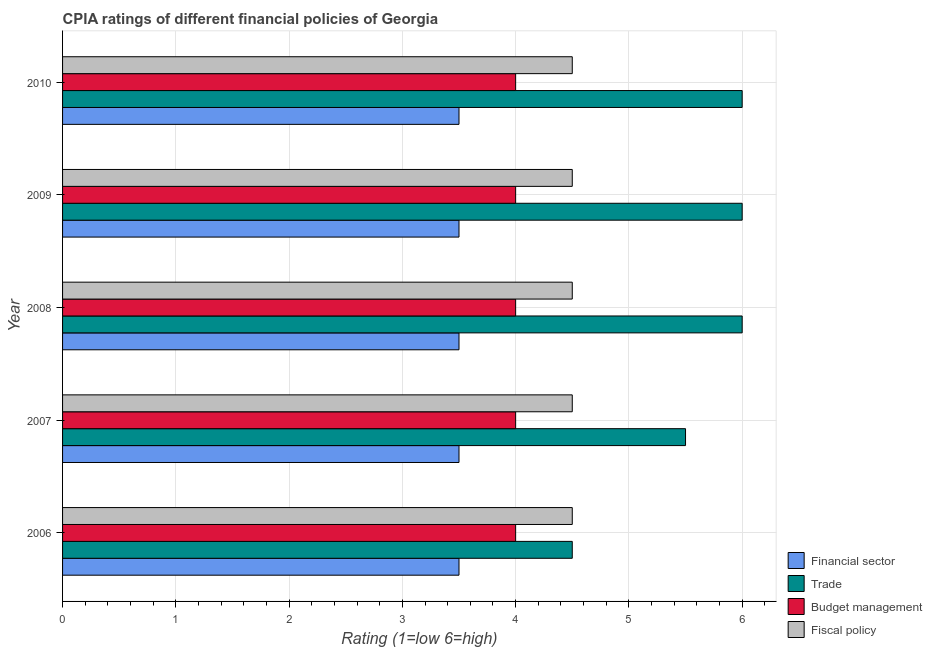How many groups of bars are there?
Provide a succinct answer. 5. How many bars are there on the 5th tick from the bottom?
Your response must be concise. 4. What is the label of the 2nd group of bars from the top?
Ensure brevity in your answer.  2009. In how many cases, is the number of bars for a given year not equal to the number of legend labels?
Keep it short and to the point. 0. What is the cpia rating of fiscal policy in 2010?
Make the answer very short. 4.5. In which year was the cpia rating of financial sector maximum?
Give a very brief answer. 2006. What is the total cpia rating of fiscal policy in the graph?
Provide a succinct answer. 22.5. What is the difference between the cpia rating of fiscal policy in 2009 and that in 2010?
Keep it short and to the point. 0. What is the difference between the cpia rating of fiscal policy in 2009 and the cpia rating of budget management in 2006?
Offer a very short reply. 0.5. What is the average cpia rating of budget management per year?
Give a very brief answer. 4. In the year 2010, what is the difference between the cpia rating of financial sector and cpia rating of fiscal policy?
Make the answer very short. -1. What is the difference between the highest and the second highest cpia rating of financial sector?
Ensure brevity in your answer.  0. What is the difference between the highest and the lowest cpia rating of financial sector?
Your answer should be compact. 0. Is the sum of the cpia rating of budget management in 2007 and 2008 greater than the maximum cpia rating of fiscal policy across all years?
Offer a terse response. Yes. What does the 3rd bar from the top in 2008 represents?
Your answer should be compact. Trade. What does the 3rd bar from the bottom in 2008 represents?
Provide a succinct answer. Budget management. Is it the case that in every year, the sum of the cpia rating of financial sector and cpia rating of trade is greater than the cpia rating of budget management?
Provide a short and direct response. Yes. How many bars are there?
Keep it short and to the point. 20. What is the difference between two consecutive major ticks on the X-axis?
Provide a short and direct response. 1. Are the values on the major ticks of X-axis written in scientific E-notation?
Your answer should be very brief. No. Does the graph contain any zero values?
Make the answer very short. No. Does the graph contain grids?
Provide a succinct answer. Yes. How many legend labels are there?
Offer a very short reply. 4. How are the legend labels stacked?
Offer a very short reply. Vertical. What is the title of the graph?
Your response must be concise. CPIA ratings of different financial policies of Georgia. Does "UNDP" appear as one of the legend labels in the graph?
Give a very brief answer. No. What is the Rating (1=low 6=high) of Financial sector in 2006?
Ensure brevity in your answer.  3.5. What is the Rating (1=low 6=high) of Trade in 2006?
Offer a very short reply. 4.5. What is the Rating (1=low 6=high) of Budget management in 2006?
Make the answer very short. 4. What is the Rating (1=low 6=high) of Fiscal policy in 2006?
Make the answer very short. 4.5. What is the Rating (1=low 6=high) in Trade in 2007?
Your answer should be very brief. 5.5. What is the Rating (1=low 6=high) in Budget management in 2007?
Provide a succinct answer. 4. What is the Rating (1=low 6=high) of Fiscal policy in 2008?
Offer a terse response. 4.5. What is the Rating (1=low 6=high) in Financial sector in 2009?
Make the answer very short. 3.5. What is the Rating (1=low 6=high) in Fiscal policy in 2009?
Your answer should be compact. 4.5. Across all years, what is the minimum Rating (1=low 6=high) in Financial sector?
Provide a short and direct response. 3.5. Across all years, what is the minimum Rating (1=low 6=high) of Budget management?
Your response must be concise. 4. Across all years, what is the minimum Rating (1=low 6=high) of Fiscal policy?
Ensure brevity in your answer.  4.5. What is the total Rating (1=low 6=high) in Trade in the graph?
Offer a very short reply. 28. What is the difference between the Rating (1=low 6=high) of Fiscal policy in 2006 and that in 2007?
Provide a succinct answer. 0. What is the difference between the Rating (1=low 6=high) in Financial sector in 2006 and that in 2008?
Ensure brevity in your answer.  0. What is the difference between the Rating (1=low 6=high) in Fiscal policy in 2006 and that in 2008?
Your response must be concise. 0. What is the difference between the Rating (1=low 6=high) of Financial sector in 2006 and that in 2009?
Give a very brief answer. 0. What is the difference between the Rating (1=low 6=high) of Budget management in 2006 and that in 2009?
Offer a very short reply. 0. What is the difference between the Rating (1=low 6=high) of Fiscal policy in 2006 and that in 2009?
Offer a terse response. 0. What is the difference between the Rating (1=low 6=high) of Financial sector in 2006 and that in 2010?
Your response must be concise. 0. What is the difference between the Rating (1=low 6=high) of Budget management in 2007 and that in 2008?
Provide a short and direct response. 0. What is the difference between the Rating (1=low 6=high) of Fiscal policy in 2007 and that in 2008?
Give a very brief answer. 0. What is the difference between the Rating (1=low 6=high) of Trade in 2007 and that in 2009?
Provide a succinct answer. -0.5. What is the difference between the Rating (1=low 6=high) in Fiscal policy in 2007 and that in 2009?
Offer a very short reply. 0. What is the difference between the Rating (1=low 6=high) in Financial sector in 2007 and that in 2010?
Give a very brief answer. 0. What is the difference between the Rating (1=low 6=high) in Financial sector in 2008 and that in 2009?
Keep it short and to the point. 0. What is the difference between the Rating (1=low 6=high) of Trade in 2008 and that in 2009?
Provide a succinct answer. 0. What is the difference between the Rating (1=low 6=high) of Fiscal policy in 2008 and that in 2009?
Your answer should be very brief. 0. What is the difference between the Rating (1=low 6=high) in Trade in 2008 and that in 2010?
Your response must be concise. 0. What is the difference between the Rating (1=low 6=high) in Fiscal policy in 2008 and that in 2010?
Offer a terse response. 0. What is the difference between the Rating (1=low 6=high) of Trade in 2009 and that in 2010?
Provide a short and direct response. 0. What is the difference between the Rating (1=low 6=high) of Financial sector in 2006 and the Rating (1=low 6=high) of Trade in 2007?
Provide a short and direct response. -2. What is the difference between the Rating (1=low 6=high) in Trade in 2006 and the Rating (1=low 6=high) in Budget management in 2007?
Provide a succinct answer. 0.5. What is the difference between the Rating (1=low 6=high) of Trade in 2006 and the Rating (1=low 6=high) of Fiscal policy in 2007?
Offer a very short reply. 0. What is the difference between the Rating (1=low 6=high) in Financial sector in 2006 and the Rating (1=low 6=high) in Trade in 2008?
Give a very brief answer. -2.5. What is the difference between the Rating (1=low 6=high) in Financial sector in 2006 and the Rating (1=low 6=high) in Budget management in 2008?
Give a very brief answer. -0.5. What is the difference between the Rating (1=low 6=high) in Financial sector in 2006 and the Rating (1=low 6=high) in Fiscal policy in 2008?
Your answer should be very brief. -1. What is the difference between the Rating (1=low 6=high) of Budget management in 2006 and the Rating (1=low 6=high) of Fiscal policy in 2008?
Your response must be concise. -0.5. What is the difference between the Rating (1=low 6=high) of Financial sector in 2006 and the Rating (1=low 6=high) of Trade in 2009?
Make the answer very short. -2.5. What is the difference between the Rating (1=low 6=high) in Financial sector in 2006 and the Rating (1=low 6=high) in Budget management in 2009?
Give a very brief answer. -0.5. What is the difference between the Rating (1=low 6=high) in Trade in 2006 and the Rating (1=low 6=high) in Budget management in 2009?
Provide a succinct answer. 0.5. What is the difference between the Rating (1=low 6=high) in Budget management in 2006 and the Rating (1=low 6=high) in Fiscal policy in 2009?
Make the answer very short. -0.5. What is the difference between the Rating (1=low 6=high) of Financial sector in 2006 and the Rating (1=low 6=high) of Budget management in 2010?
Make the answer very short. -0.5. What is the difference between the Rating (1=low 6=high) in Budget management in 2006 and the Rating (1=low 6=high) in Fiscal policy in 2010?
Give a very brief answer. -0.5. What is the difference between the Rating (1=low 6=high) in Financial sector in 2007 and the Rating (1=low 6=high) in Trade in 2008?
Your response must be concise. -2.5. What is the difference between the Rating (1=low 6=high) in Trade in 2007 and the Rating (1=low 6=high) in Fiscal policy in 2008?
Your response must be concise. 1. What is the difference between the Rating (1=low 6=high) of Budget management in 2007 and the Rating (1=low 6=high) of Fiscal policy in 2008?
Ensure brevity in your answer.  -0.5. What is the difference between the Rating (1=low 6=high) of Financial sector in 2007 and the Rating (1=low 6=high) of Budget management in 2009?
Offer a terse response. -0.5. What is the difference between the Rating (1=low 6=high) in Financial sector in 2007 and the Rating (1=low 6=high) in Fiscal policy in 2009?
Provide a succinct answer. -1. What is the difference between the Rating (1=low 6=high) of Trade in 2007 and the Rating (1=low 6=high) of Budget management in 2009?
Your response must be concise. 1.5. What is the difference between the Rating (1=low 6=high) in Trade in 2007 and the Rating (1=low 6=high) in Fiscal policy in 2009?
Offer a terse response. 1. What is the difference between the Rating (1=low 6=high) of Financial sector in 2007 and the Rating (1=low 6=high) of Trade in 2010?
Ensure brevity in your answer.  -2.5. What is the difference between the Rating (1=low 6=high) in Trade in 2007 and the Rating (1=low 6=high) in Fiscal policy in 2010?
Keep it short and to the point. 1. What is the difference between the Rating (1=low 6=high) of Trade in 2008 and the Rating (1=low 6=high) of Budget management in 2009?
Offer a terse response. 2. What is the difference between the Rating (1=low 6=high) of Budget management in 2008 and the Rating (1=low 6=high) of Fiscal policy in 2009?
Your answer should be very brief. -0.5. What is the difference between the Rating (1=low 6=high) in Financial sector in 2008 and the Rating (1=low 6=high) in Budget management in 2010?
Offer a very short reply. -0.5. What is the difference between the Rating (1=low 6=high) of Financial sector in 2009 and the Rating (1=low 6=high) of Trade in 2010?
Your answer should be compact. -2.5. What is the difference between the Rating (1=low 6=high) in Financial sector in 2009 and the Rating (1=low 6=high) in Fiscal policy in 2010?
Your answer should be very brief. -1. What is the average Rating (1=low 6=high) in Financial sector per year?
Offer a terse response. 3.5. What is the average Rating (1=low 6=high) of Trade per year?
Give a very brief answer. 5.6. What is the average Rating (1=low 6=high) in Budget management per year?
Give a very brief answer. 4. In the year 2006, what is the difference between the Rating (1=low 6=high) in Financial sector and Rating (1=low 6=high) in Trade?
Ensure brevity in your answer.  -1. In the year 2006, what is the difference between the Rating (1=low 6=high) in Trade and Rating (1=low 6=high) in Budget management?
Give a very brief answer. 0.5. In the year 2006, what is the difference between the Rating (1=low 6=high) of Budget management and Rating (1=low 6=high) of Fiscal policy?
Keep it short and to the point. -0.5. In the year 2007, what is the difference between the Rating (1=low 6=high) in Financial sector and Rating (1=low 6=high) in Fiscal policy?
Offer a terse response. -1. In the year 2007, what is the difference between the Rating (1=low 6=high) in Trade and Rating (1=low 6=high) in Budget management?
Provide a succinct answer. 1.5. In the year 2007, what is the difference between the Rating (1=low 6=high) in Trade and Rating (1=low 6=high) in Fiscal policy?
Provide a succinct answer. 1. In the year 2008, what is the difference between the Rating (1=low 6=high) in Financial sector and Rating (1=low 6=high) in Trade?
Provide a short and direct response. -2.5. In the year 2009, what is the difference between the Rating (1=low 6=high) in Trade and Rating (1=low 6=high) in Budget management?
Give a very brief answer. 2. In the year 2009, what is the difference between the Rating (1=low 6=high) of Trade and Rating (1=low 6=high) of Fiscal policy?
Your answer should be compact. 1.5. In the year 2010, what is the difference between the Rating (1=low 6=high) in Financial sector and Rating (1=low 6=high) in Trade?
Offer a terse response. -2.5. In the year 2010, what is the difference between the Rating (1=low 6=high) of Financial sector and Rating (1=low 6=high) of Fiscal policy?
Ensure brevity in your answer.  -1. What is the ratio of the Rating (1=low 6=high) in Financial sector in 2006 to that in 2007?
Provide a succinct answer. 1. What is the ratio of the Rating (1=low 6=high) in Trade in 2006 to that in 2007?
Offer a very short reply. 0.82. What is the ratio of the Rating (1=low 6=high) in Trade in 2006 to that in 2008?
Provide a succinct answer. 0.75. What is the ratio of the Rating (1=low 6=high) of Fiscal policy in 2006 to that in 2008?
Ensure brevity in your answer.  1. What is the ratio of the Rating (1=low 6=high) of Trade in 2006 to that in 2009?
Keep it short and to the point. 0.75. What is the ratio of the Rating (1=low 6=high) of Fiscal policy in 2006 to that in 2009?
Give a very brief answer. 1. What is the ratio of the Rating (1=low 6=high) of Financial sector in 2006 to that in 2010?
Your answer should be compact. 1. What is the ratio of the Rating (1=low 6=high) of Budget management in 2006 to that in 2010?
Ensure brevity in your answer.  1. What is the ratio of the Rating (1=low 6=high) in Fiscal policy in 2006 to that in 2010?
Provide a succinct answer. 1. What is the ratio of the Rating (1=low 6=high) of Fiscal policy in 2007 to that in 2008?
Offer a very short reply. 1. What is the ratio of the Rating (1=low 6=high) in Financial sector in 2007 to that in 2009?
Keep it short and to the point. 1. What is the ratio of the Rating (1=low 6=high) in Fiscal policy in 2007 to that in 2009?
Provide a short and direct response. 1. What is the ratio of the Rating (1=low 6=high) of Financial sector in 2007 to that in 2010?
Your response must be concise. 1. What is the ratio of the Rating (1=low 6=high) of Trade in 2007 to that in 2010?
Give a very brief answer. 0.92. What is the ratio of the Rating (1=low 6=high) of Budget management in 2007 to that in 2010?
Keep it short and to the point. 1. What is the ratio of the Rating (1=low 6=high) of Financial sector in 2008 to that in 2009?
Ensure brevity in your answer.  1. What is the ratio of the Rating (1=low 6=high) of Trade in 2008 to that in 2009?
Your answer should be very brief. 1. What is the ratio of the Rating (1=low 6=high) of Budget management in 2008 to that in 2009?
Keep it short and to the point. 1. What is the ratio of the Rating (1=low 6=high) in Fiscal policy in 2008 to that in 2009?
Give a very brief answer. 1. What is the ratio of the Rating (1=low 6=high) of Financial sector in 2008 to that in 2010?
Give a very brief answer. 1. What is the ratio of the Rating (1=low 6=high) of Trade in 2008 to that in 2010?
Offer a terse response. 1. What is the ratio of the Rating (1=low 6=high) in Financial sector in 2009 to that in 2010?
Your answer should be very brief. 1. What is the ratio of the Rating (1=low 6=high) in Trade in 2009 to that in 2010?
Provide a short and direct response. 1. What is the ratio of the Rating (1=low 6=high) of Budget management in 2009 to that in 2010?
Provide a short and direct response. 1. What is the difference between the highest and the second highest Rating (1=low 6=high) in Trade?
Provide a succinct answer. 0. What is the difference between the highest and the second highest Rating (1=low 6=high) in Budget management?
Ensure brevity in your answer.  0. What is the difference between the highest and the lowest Rating (1=low 6=high) in Financial sector?
Your response must be concise. 0. What is the difference between the highest and the lowest Rating (1=low 6=high) in Budget management?
Your response must be concise. 0. What is the difference between the highest and the lowest Rating (1=low 6=high) of Fiscal policy?
Offer a very short reply. 0. 